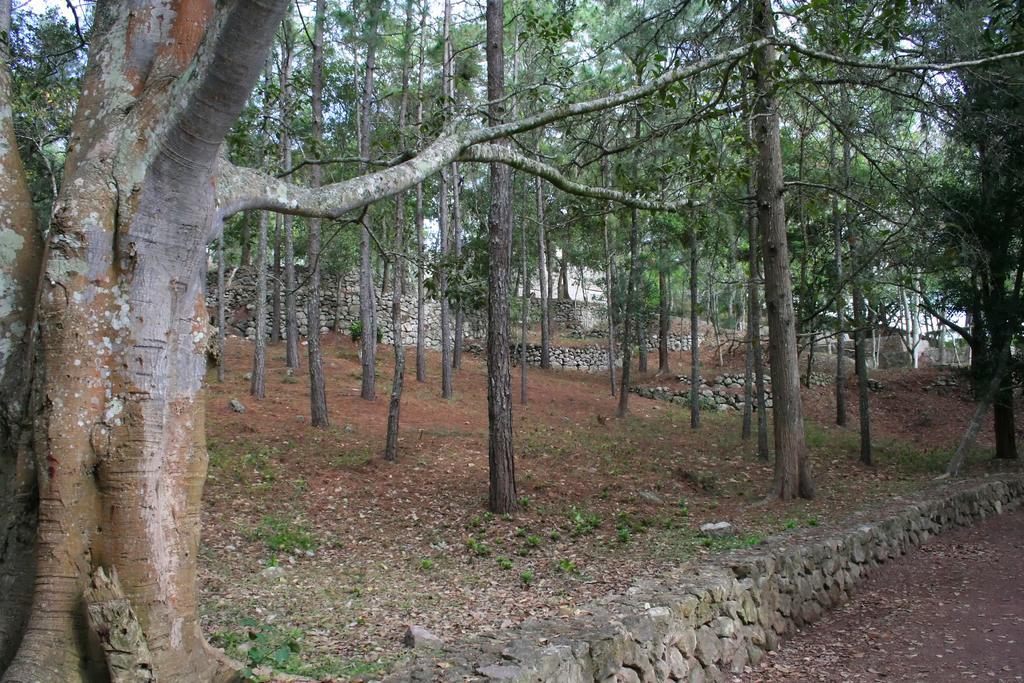Describe this image in one or two sentences. In this picture I can see there are many trees here and there is soil, grass and small plants on the floor and in the backdrop it looks like there is a building and there are dry leaves on the floor at right side. 